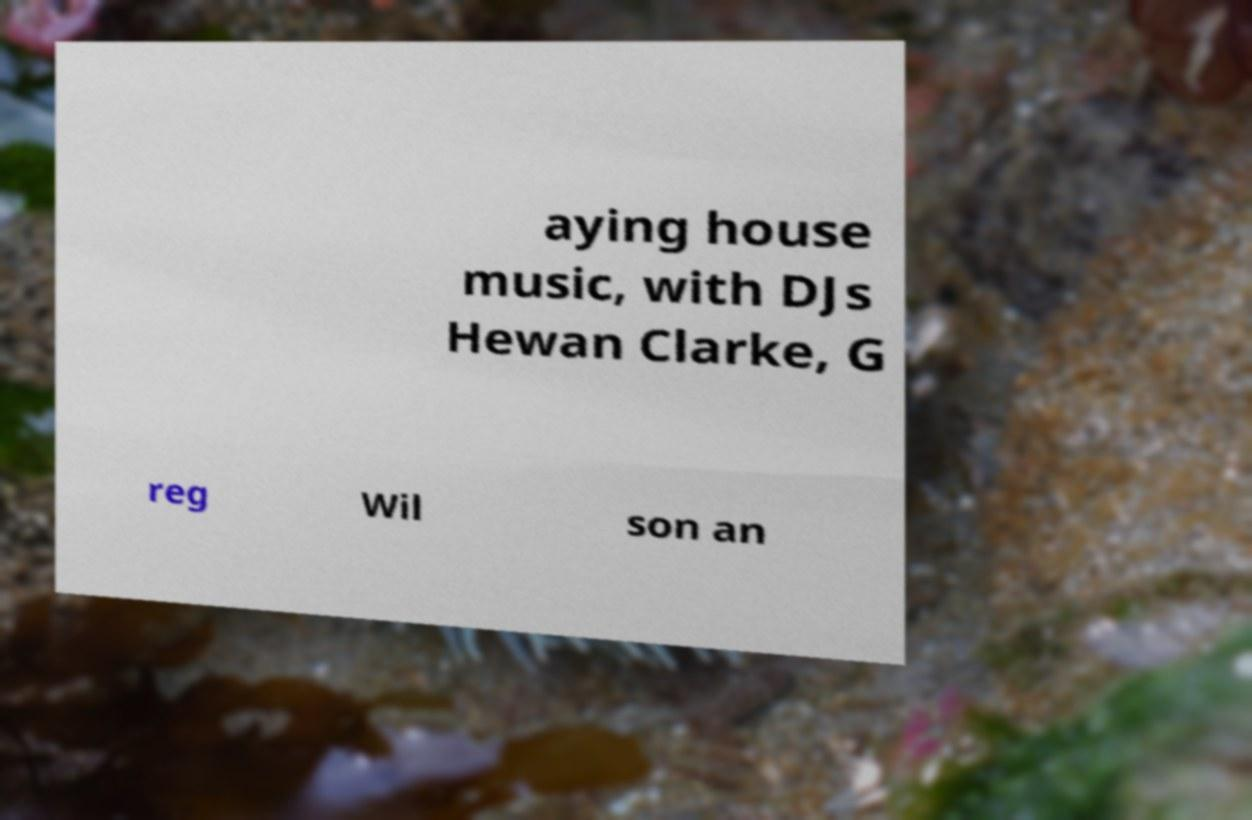Can you accurately transcribe the text from the provided image for me? aying house music, with DJs Hewan Clarke, G reg Wil son an 